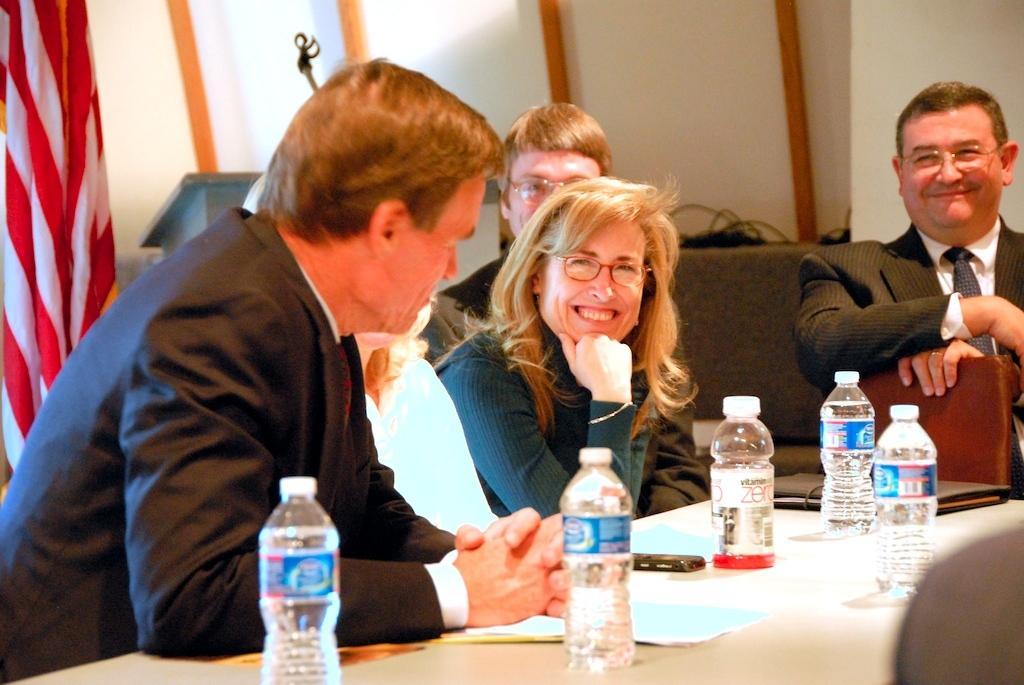How would you summarize this image in a sentence or two? In this image we can see a few people sitting on the chairs, in front of them, we can see a table, on the table there are some water bottles, papers and some other objects, in the background we can see a flag, podium and the wall. 